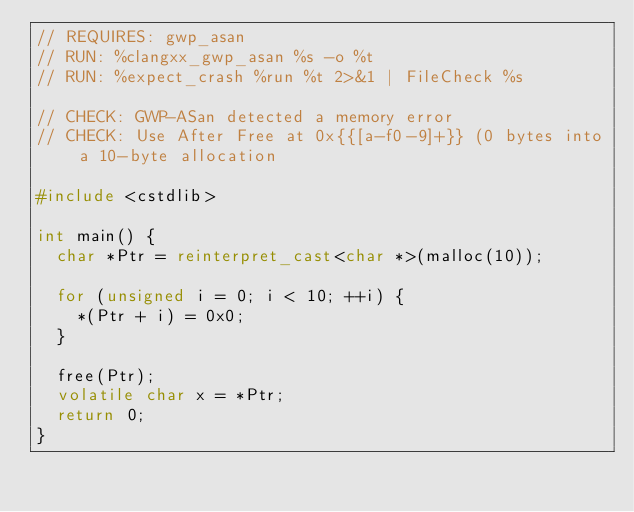<code> <loc_0><loc_0><loc_500><loc_500><_C++_>// REQUIRES: gwp_asan
// RUN: %clangxx_gwp_asan %s -o %t
// RUN: %expect_crash %run %t 2>&1 | FileCheck %s

// CHECK: GWP-ASan detected a memory error
// CHECK: Use After Free at 0x{{[a-f0-9]+}} (0 bytes into a 10-byte allocation

#include <cstdlib>

int main() {
  char *Ptr = reinterpret_cast<char *>(malloc(10));

  for (unsigned i = 0; i < 10; ++i) {
    *(Ptr + i) = 0x0;
  }

  free(Ptr);
  volatile char x = *Ptr;
  return 0;
}
</code> 